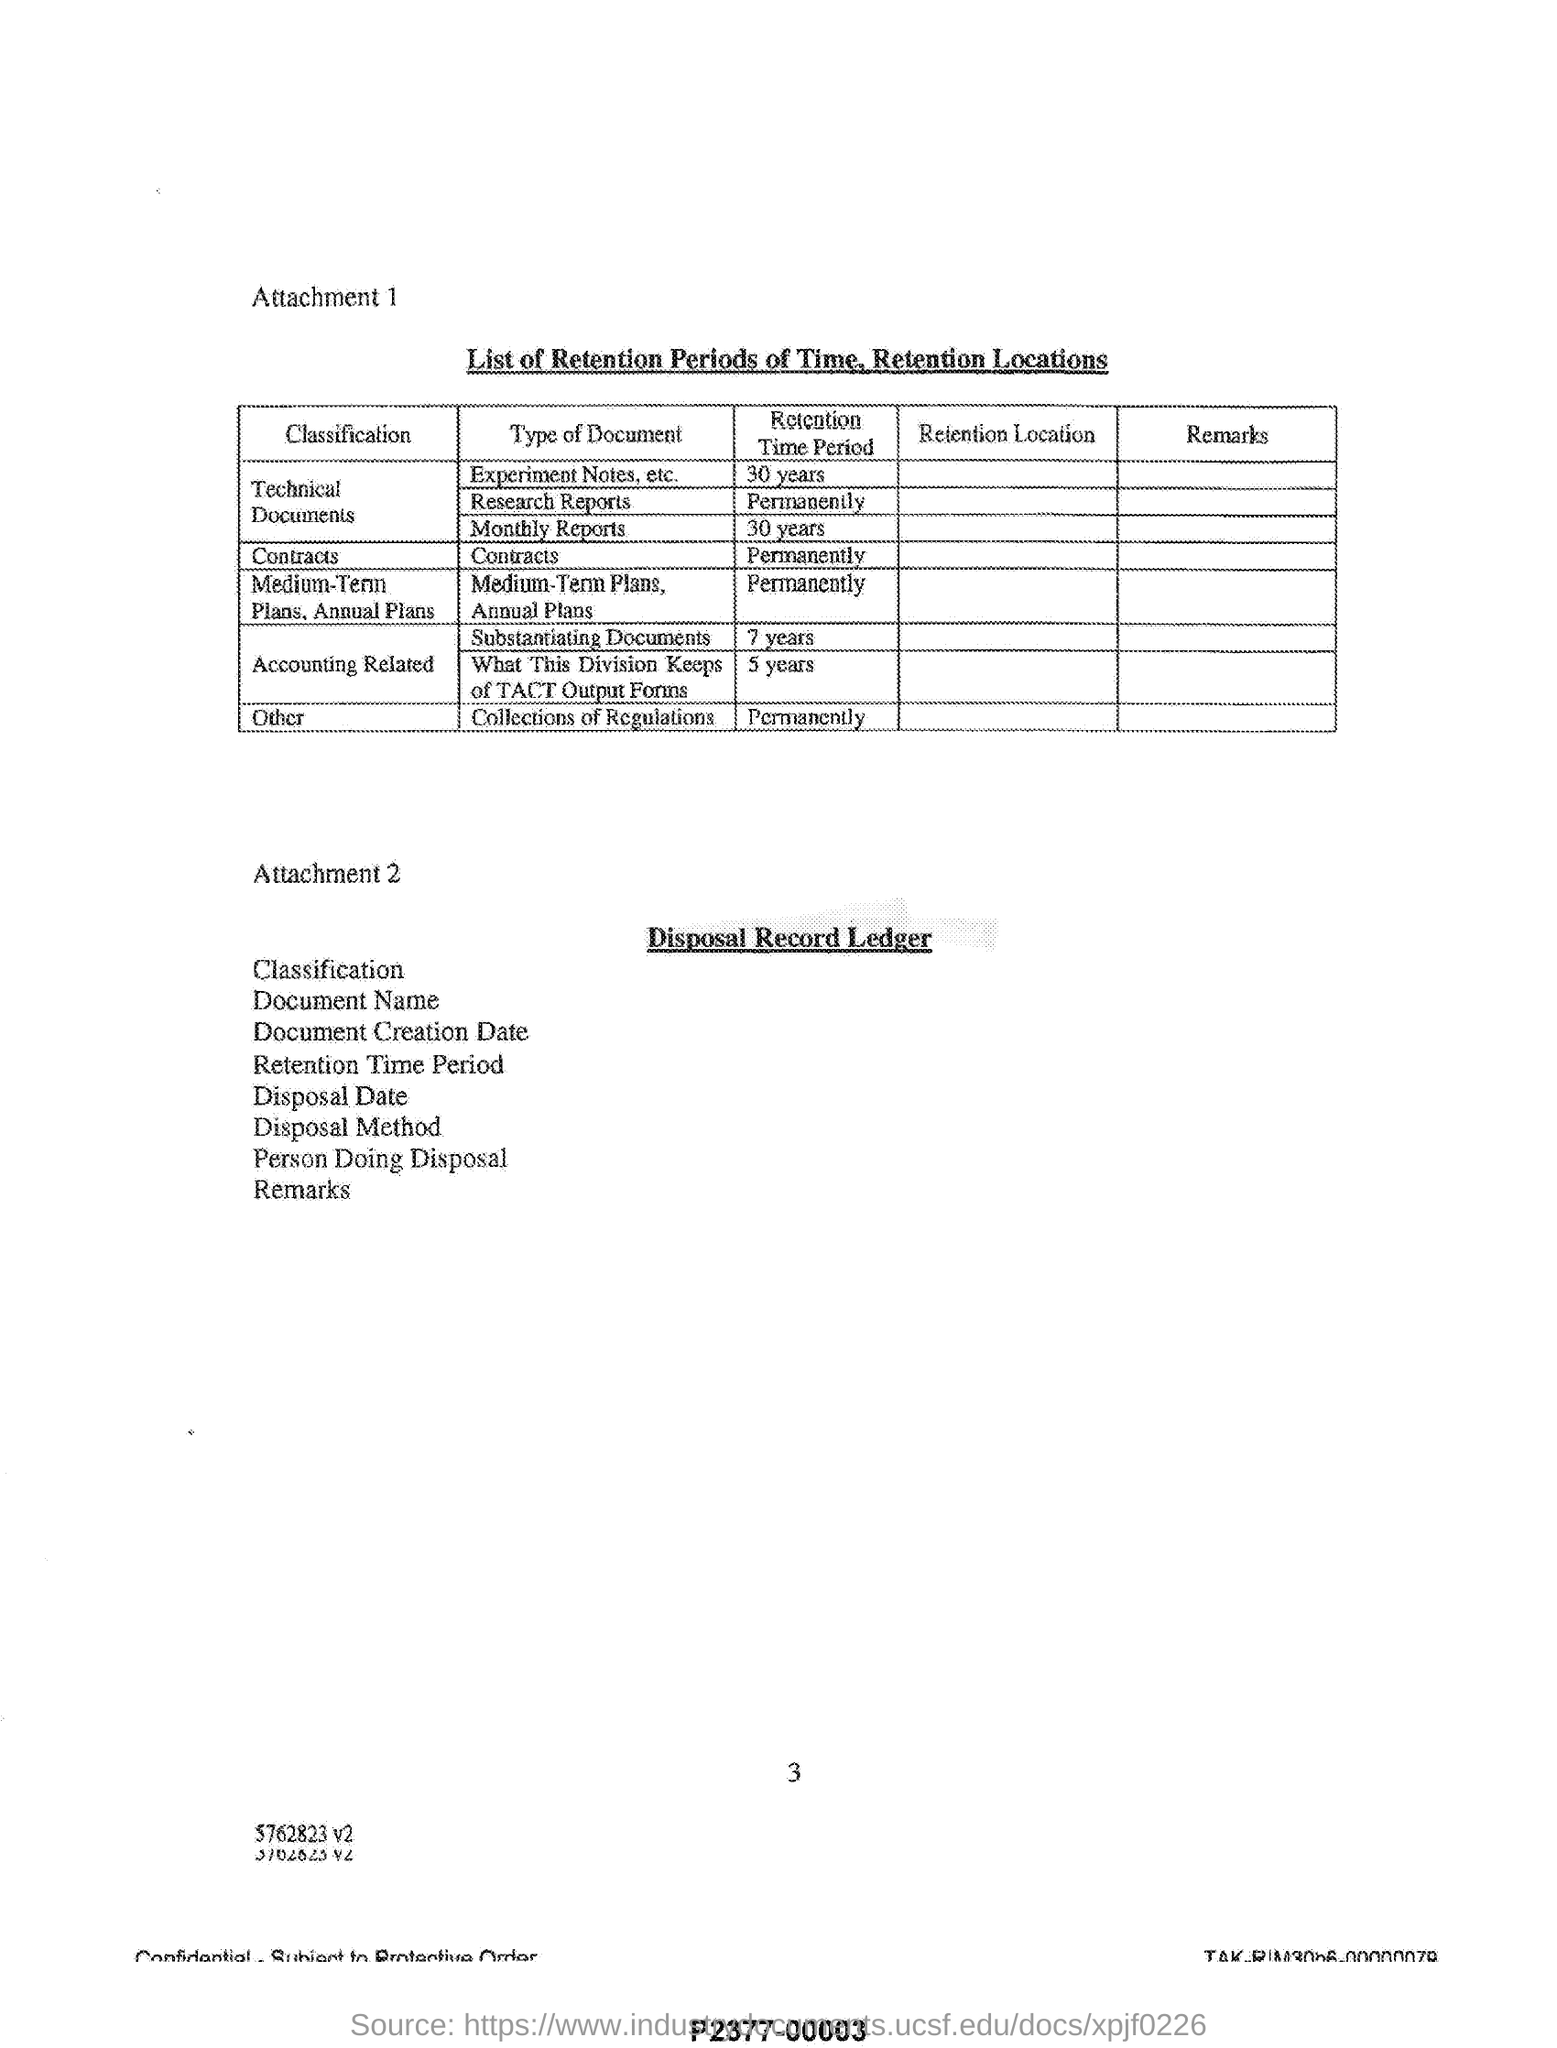Give some essential details in this illustration. The retention period for contracts is indefinitely permanent. Attachment 1 provides a description of retention periods and locations for various types of data. The retention period for monthly reports is 30 years. 